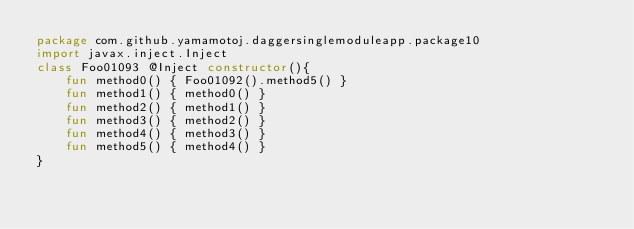Convert code to text. <code><loc_0><loc_0><loc_500><loc_500><_Kotlin_>package com.github.yamamotoj.daggersinglemoduleapp.package10
import javax.inject.Inject
class Foo01093 @Inject constructor(){
    fun method0() { Foo01092().method5() }
    fun method1() { method0() }
    fun method2() { method1() }
    fun method3() { method2() }
    fun method4() { method3() }
    fun method5() { method4() }
}
</code> 